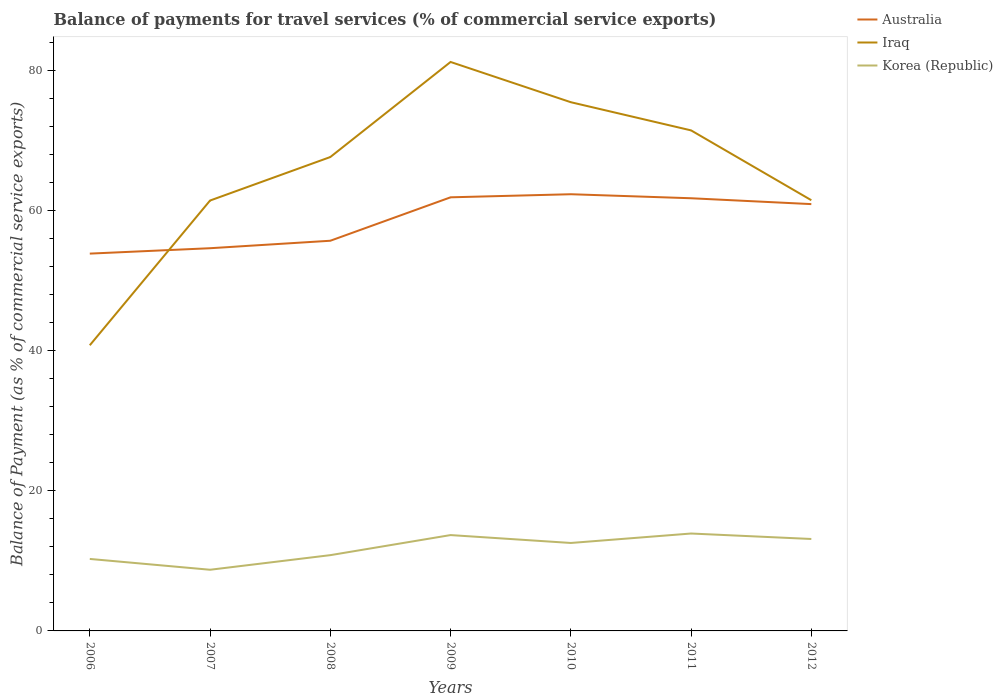Does the line corresponding to Iraq intersect with the line corresponding to Australia?
Keep it short and to the point. Yes. Across all years, what is the maximum balance of payments for travel services in Australia?
Make the answer very short. 53.87. In which year was the balance of payments for travel services in Korea (Republic) maximum?
Provide a short and direct response. 2007. What is the total balance of payments for travel services in Korea (Republic) in the graph?
Make the answer very short. 1.13. What is the difference between the highest and the second highest balance of payments for travel services in Australia?
Ensure brevity in your answer.  8.48. What is the difference between the highest and the lowest balance of payments for travel services in Iraq?
Offer a terse response. 4. Is the balance of payments for travel services in Australia strictly greater than the balance of payments for travel services in Iraq over the years?
Make the answer very short. No. Are the values on the major ticks of Y-axis written in scientific E-notation?
Your answer should be very brief. No. Where does the legend appear in the graph?
Keep it short and to the point. Top right. What is the title of the graph?
Your answer should be very brief. Balance of payments for travel services (% of commercial service exports). What is the label or title of the Y-axis?
Ensure brevity in your answer.  Balance of Payment (as % of commercial service exports). What is the Balance of Payment (as % of commercial service exports) of Australia in 2006?
Offer a terse response. 53.87. What is the Balance of Payment (as % of commercial service exports) in Iraq in 2006?
Provide a short and direct response. 40.79. What is the Balance of Payment (as % of commercial service exports) in Korea (Republic) in 2006?
Offer a very short reply. 10.28. What is the Balance of Payment (as % of commercial service exports) in Australia in 2007?
Your response must be concise. 54.64. What is the Balance of Payment (as % of commercial service exports) in Iraq in 2007?
Your answer should be compact. 61.45. What is the Balance of Payment (as % of commercial service exports) of Korea (Republic) in 2007?
Ensure brevity in your answer.  8.73. What is the Balance of Payment (as % of commercial service exports) in Australia in 2008?
Make the answer very short. 55.71. What is the Balance of Payment (as % of commercial service exports) of Iraq in 2008?
Make the answer very short. 67.66. What is the Balance of Payment (as % of commercial service exports) of Korea (Republic) in 2008?
Keep it short and to the point. 10.82. What is the Balance of Payment (as % of commercial service exports) of Australia in 2009?
Your answer should be very brief. 61.91. What is the Balance of Payment (as % of commercial service exports) of Iraq in 2009?
Your answer should be compact. 81.24. What is the Balance of Payment (as % of commercial service exports) in Korea (Republic) in 2009?
Provide a succinct answer. 13.68. What is the Balance of Payment (as % of commercial service exports) of Australia in 2010?
Ensure brevity in your answer.  62.35. What is the Balance of Payment (as % of commercial service exports) of Iraq in 2010?
Your response must be concise. 75.49. What is the Balance of Payment (as % of commercial service exports) of Korea (Republic) in 2010?
Offer a terse response. 12.56. What is the Balance of Payment (as % of commercial service exports) in Australia in 2011?
Make the answer very short. 61.78. What is the Balance of Payment (as % of commercial service exports) in Iraq in 2011?
Provide a short and direct response. 71.47. What is the Balance of Payment (as % of commercial service exports) in Korea (Republic) in 2011?
Your answer should be very brief. 13.91. What is the Balance of Payment (as % of commercial service exports) in Australia in 2012?
Ensure brevity in your answer.  60.94. What is the Balance of Payment (as % of commercial service exports) of Iraq in 2012?
Ensure brevity in your answer.  61.5. What is the Balance of Payment (as % of commercial service exports) of Korea (Republic) in 2012?
Provide a succinct answer. 13.13. Across all years, what is the maximum Balance of Payment (as % of commercial service exports) in Australia?
Make the answer very short. 62.35. Across all years, what is the maximum Balance of Payment (as % of commercial service exports) in Iraq?
Make the answer very short. 81.24. Across all years, what is the maximum Balance of Payment (as % of commercial service exports) in Korea (Republic)?
Offer a terse response. 13.91. Across all years, what is the minimum Balance of Payment (as % of commercial service exports) in Australia?
Keep it short and to the point. 53.87. Across all years, what is the minimum Balance of Payment (as % of commercial service exports) of Iraq?
Offer a very short reply. 40.79. Across all years, what is the minimum Balance of Payment (as % of commercial service exports) in Korea (Republic)?
Offer a terse response. 8.73. What is the total Balance of Payment (as % of commercial service exports) of Australia in the graph?
Your answer should be very brief. 411.21. What is the total Balance of Payment (as % of commercial service exports) in Iraq in the graph?
Your answer should be very brief. 459.59. What is the total Balance of Payment (as % of commercial service exports) of Korea (Republic) in the graph?
Give a very brief answer. 83.11. What is the difference between the Balance of Payment (as % of commercial service exports) in Australia in 2006 and that in 2007?
Give a very brief answer. -0.77. What is the difference between the Balance of Payment (as % of commercial service exports) in Iraq in 2006 and that in 2007?
Provide a short and direct response. -20.66. What is the difference between the Balance of Payment (as % of commercial service exports) in Korea (Republic) in 2006 and that in 2007?
Give a very brief answer. 1.54. What is the difference between the Balance of Payment (as % of commercial service exports) in Australia in 2006 and that in 2008?
Make the answer very short. -1.83. What is the difference between the Balance of Payment (as % of commercial service exports) of Iraq in 2006 and that in 2008?
Give a very brief answer. -26.88. What is the difference between the Balance of Payment (as % of commercial service exports) in Korea (Republic) in 2006 and that in 2008?
Offer a terse response. -0.54. What is the difference between the Balance of Payment (as % of commercial service exports) of Australia in 2006 and that in 2009?
Provide a succinct answer. -8.04. What is the difference between the Balance of Payment (as % of commercial service exports) in Iraq in 2006 and that in 2009?
Your answer should be compact. -40.45. What is the difference between the Balance of Payment (as % of commercial service exports) of Korea (Republic) in 2006 and that in 2009?
Give a very brief answer. -3.41. What is the difference between the Balance of Payment (as % of commercial service exports) in Australia in 2006 and that in 2010?
Provide a succinct answer. -8.48. What is the difference between the Balance of Payment (as % of commercial service exports) in Iraq in 2006 and that in 2010?
Offer a very short reply. -34.7. What is the difference between the Balance of Payment (as % of commercial service exports) in Korea (Republic) in 2006 and that in 2010?
Provide a succinct answer. -2.28. What is the difference between the Balance of Payment (as % of commercial service exports) of Australia in 2006 and that in 2011?
Keep it short and to the point. -7.9. What is the difference between the Balance of Payment (as % of commercial service exports) of Iraq in 2006 and that in 2011?
Give a very brief answer. -30.68. What is the difference between the Balance of Payment (as % of commercial service exports) of Korea (Republic) in 2006 and that in 2011?
Give a very brief answer. -3.63. What is the difference between the Balance of Payment (as % of commercial service exports) of Australia in 2006 and that in 2012?
Provide a succinct answer. -7.07. What is the difference between the Balance of Payment (as % of commercial service exports) in Iraq in 2006 and that in 2012?
Offer a terse response. -20.71. What is the difference between the Balance of Payment (as % of commercial service exports) of Korea (Republic) in 2006 and that in 2012?
Your answer should be very brief. -2.85. What is the difference between the Balance of Payment (as % of commercial service exports) in Australia in 2007 and that in 2008?
Your answer should be compact. -1.07. What is the difference between the Balance of Payment (as % of commercial service exports) in Iraq in 2007 and that in 2008?
Your response must be concise. -6.21. What is the difference between the Balance of Payment (as % of commercial service exports) of Korea (Republic) in 2007 and that in 2008?
Give a very brief answer. -2.08. What is the difference between the Balance of Payment (as % of commercial service exports) in Australia in 2007 and that in 2009?
Your answer should be very brief. -7.27. What is the difference between the Balance of Payment (as % of commercial service exports) in Iraq in 2007 and that in 2009?
Provide a short and direct response. -19.79. What is the difference between the Balance of Payment (as % of commercial service exports) of Korea (Republic) in 2007 and that in 2009?
Offer a terse response. -4.95. What is the difference between the Balance of Payment (as % of commercial service exports) of Australia in 2007 and that in 2010?
Keep it short and to the point. -7.71. What is the difference between the Balance of Payment (as % of commercial service exports) in Iraq in 2007 and that in 2010?
Provide a succinct answer. -14.04. What is the difference between the Balance of Payment (as % of commercial service exports) in Korea (Republic) in 2007 and that in 2010?
Provide a short and direct response. -3.82. What is the difference between the Balance of Payment (as % of commercial service exports) of Australia in 2007 and that in 2011?
Your answer should be compact. -7.13. What is the difference between the Balance of Payment (as % of commercial service exports) in Iraq in 2007 and that in 2011?
Ensure brevity in your answer.  -10.02. What is the difference between the Balance of Payment (as % of commercial service exports) in Korea (Republic) in 2007 and that in 2011?
Your response must be concise. -5.17. What is the difference between the Balance of Payment (as % of commercial service exports) in Australia in 2007 and that in 2012?
Provide a succinct answer. -6.3. What is the difference between the Balance of Payment (as % of commercial service exports) of Iraq in 2007 and that in 2012?
Make the answer very short. -0.05. What is the difference between the Balance of Payment (as % of commercial service exports) in Korea (Republic) in 2007 and that in 2012?
Provide a succinct answer. -4.39. What is the difference between the Balance of Payment (as % of commercial service exports) in Australia in 2008 and that in 2009?
Provide a succinct answer. -6.2. What is the difference between the Balance of Payment (as % of commercial service exports) of Iraq in 2008 and that in 2009?
Your response must be concise. -13.57. What is the difference between the Balance of Payment (as % of commercial service exports) in Korea (Republic) in 2008 and that in 2009?
Keep it short and to the point. -2.87. What is the difference between the Balance of Payment (as % of commercial service exports) of Australia in 2008 and that in 2010?
Make the answer very short. -6.64. What is the difference between the Balance of Payment (as % of commercial service exports) of Iraq in 2008 and that in 2010?
Your answer should be compact. -7.83. What is the difference between the Balance of Payment (as % of commercial service exports) in Korea (Republic) in 2008 and that in 2010?
Your response must be concise. -1.74. What is the difference between the Balance of Payment (as % of commercial service exports) of Australia in 2008 and that in 2011?
Your answer should be very brief. -6.07. What is the difference between the Balance of Payment (as % of commercial service exports) in Iraq in 2008 and that in 2011?
Your response must be concise. -3.81. What is the difference between the Balance of Payment (as % of commercial service exports) in Korea (Republic) in 2008 and that in 2011?
Give a very brief answer. -3.09. What is the difference between the Balance of Payment (as % of commercial service exports) of Australia in 2008 and that in 2012?
Keep it short and to the point. -5.23. What is the difference between the Balance of Payment (as % of commercial service exports) of Iraq in 2008 and that in 2012?
Your answer should be very brief. 6.16. What is the difference between the Balance of Payment (as % of commercial service exports) of Korea (Republic) in 2008 and that in 2012?
Your response must be concise. -2.31. What is the difference between the Balance of Payment (as % of commercial service exports) of Australia in 2009 and that in 2010?
Give a very brief answer. -0.44. What is the difference between the Balance of Payment (as % of commercial service exports) of Iraq in 2009 and that in 2010?
Provide a short and direct response. 5.75. What is the difference between the Balance of Payment (as % of commercial service exports) of Korea (Republic) in 2009 and that in 2010?
Your answer should be very brief. 1.13. What is the difference between the Balance of Payment (as % of commercial service exports) in Australia in 2009 and that in 2011?
Ensure brevity in your answer.  0.13. What is the difference between the Balance of Payment (as % of commercial service exports) in Iraq in 2009 and that in 2011?
Keep it short and to the point. 9.77. What is the difference between the Balance of Payment (as % of commercial service exports) in Korea (Republic) in 2009 and that in 2011?
Offer a very short reply. -0.22. What is the difference between the Balance of Payment (as % of commercial service exports) in Australia in 2009 and that in 2012?
Ensure brevity in your answer.  0.97. What is the difference between the Balance of Payment (as % of commercial service exports) in Iraq in 2009 and that in 2012?
Your answer should be compact. 19.74. What is the difference between the Balance of Payment (as % of commercial service exports) of Korea (Republic) in 2009 and that in 2012?
Your answer should be very brief. 0.56. What is the difference between the Balance of Payment (as % of commercial service exports) in Australia in 2010 and that in 2011?
Give a very brief answer. 0.57. What is the difference between the Balance of Payment (as % of commercial service exports) in Iraq in 2010 and that in 2011?
Keep it short and to the point. 4.02. What is the difference between the Balance of Payment (as % of commercial service exports) in Korea (Republic) in 2010 and that in 2011?
Offer a terse response. -1.35. What is the difference between the Balance of Payment (as % of commercial service exports) of Australia in 2010 and that in 2012?
Offer a terse response. 1.41. What is the difference between the Balance of Payment (as % of commercial service exports) in Iraq in 2010 and that in 2012?
Your response must be concise. 13.99. What is the difference between the Balance of Payment (as % of commercial service exports) of Korea (Republic) in 2010 and that in 2012?
Offer a very short reply. -0.57. What is the difference between the Balance of Payment (as % of commercial service exports) of Australia in 2011 and that in 2012?
Give a very brief answer. 0.84. What is the difference between the Balance of Payment (as % of commercial service exports) in Iraq in 2011 and that in 2012?
Make the answer very short. 9.97. What is the difference between the Balance of Payment (as % of commercial service exports) of Korea (Republic) in 2011 and that in 2012?
Your response must be concise. 0.78. What is the difference between the Balance of Payment (as % of commercial service exports) of Australia in 2006 and the Balance of Payment (as % of commercial service exports) of Iraq in 2007?
Your answer should be compact. -7.58. What is the difference between the Balance of Payment (as % of commercial service exports) in Australia in 2006 and the Balance of Payment (as % of commercial service exports) in Korea (Republic) in 2007?
Your response must be concise. 45.14. What is the difference between the Balance of Payment (as % of commercial service exports) of Iraq in 2006 and the Balance of Payment (as % of commercial service exports) of Korea (Republic) in 2007?
Provide a succinct answer. 32.05. What is the difference between the Balance of Payment (as % of commercial service exports) of Australia in 2006 and the Balance of Payment (as % of commercial service exports) of Iraq in 2008?
Ensure brevity in your answer.  -13.79. What is the difference between the Balance of Payment (as % of commercial service exports) of Australia in 2006 and the Balance of Payment (as % of commercial service exports) of Korea (Republic) in 2008?
Keep it short and to the point. 43.06. What is the difference between the Balance of Payment (as % of commercial service exports) in Iraq in 2006 and the Balance of Payment (as % of commercial service exports) in Korea (Republic) in 2008?
Your answer should be compact. 29.97. What is the difference between the Balance of Payment (as % of commercial service exports) in Australia in 2006 and the Balance of Payment (as % of commercial service exports) in Iraq in 2009?
Your answer should be compact. -27.36. What is the difference between the Balance of Payment (as % of commercial service exports) in Australia in 2006 and the Balance of Payment (as % of commercial service exports) in Korea (Republic) in 2009?
Your answer should be very brief. 40.19. What is the difference between the Balance of Payment (as % of commercial service exports) of Iraq in 2006 and the Balance of Payment (as % of commercial service exports) of Korea (Republic) in 2009?
Provide a succinct answer. 27.1. What is the difference between the Balance of Payment (as % of commercial service exports) of Australia in 2006 and the Balance of Payment (as % of commercial service exports) of Iraq in 2010?
Your answer should be very brief. -21.62. What is the difference between the Balance of Payment (as % of commercial service exports) of Australia in 2006 and the Balance of Payment (as % of commercial service exports) of Korea (Republic) in 2010?
Offer a terse response. 41.32. What is the difference between the Balance of Payment (as % of commercial service exports) of Iraq in 2006 and the Balance of Payment (as % of commercial service exports) of Korea (Republic) in 2010?
Offer a terse response. 28.23. What is the difference between the Balance of Payment (as % of commercial service exports) in Australia in 2006 and the Balance of Payment (as % of commercial service exports) in Iraq in 2011?
Your answer should be very brief. -17.59. What is the difference between the Balance of Payment (as % of commercial service exports) of Australia in 2006 and the Balance of Payment (as % of commercial service exports) of Korea (Republic) in 2011?
Give a very brief answer. 39.97. What is the difference between the Balance of Payment (as % of commercial service exports) of Iraq in 2006 and the Balance of Payment (as % of commercial service exports) of Korea (Republic) in 2011?
Give a very brief answer. 26.88. What is the difference between the Balance of Payment (as % of commercial service exports) in Australia in 2006 and the Balance of Payment (as % of commercial service exports) in Iraq in 2012?
Your response must be concise. -7.62. What is the difference between the Balance of Payment (as % of commercial service exports) of Australia in 2006 and the Balance of Payment (as % of commercial service exports) of Korea (Republic) in 2012?
Ensure brevity in your answer.  40.75. What is the difference between the Balance of Payment (as % of commercial service exports) of Iraq in 2006 and the Balance of Payment (as % of commercial service exports) of Korea (Republic) in 2012?
Provide a short and direct response. 27.66. What is the difference between the Balance of Payment (as % of commercial service exports) in Australia in 2007 and the Balance of Payment (as % of commercial service exports) in Iraq in 2008?
Offer a very short reply. -13.02. What is the difference between the Balance of Payment (as % of commercial service exports) in Australia in 2007 and the Balance of Payment (as % of commercial service exports) in Korea (Republic) in 2008?
Ensure brevity in your answer.  43.82. What is the difference between the Balance of Payment (as % of commercial service exports) in Iraq in 2007 and the Balance of Payment (as % of commercial service exports) in Korea (Republic) in 2008?
Your response must be concise. 50.63. What is the difference between the Balance of Payment (as % of commercial service exports) in Australia in 2007 and the Balance of Payment (as % of commercial service exports) in Iraq in 2009?
Ensure brevity in your answer.  -26.59. What is the difference between the Balance of Payment (as % of commercial service exports) of Australia in 2007 and the Balance of Payment (as % of commercial service exports) of Korea (Republic) in 2009?
Your answer should be very brief. 40.96. What is the difference between the Balance of Payment (as % of commercial service exports) of Iraq in 2007 and the Balance of Payment (as % of commercial service exports) of Korea (Republic) in 2009?
Offer a terse response. 47.77. What is the difference between the Balance of Payment (as % of commercial service exports) in Australia in 2007 and the Balance of Payment (as % of commercial service exports) in Iraq in 2010?
Offer a very short reply. -20.85. What is the difference between the Balance of Payment (as % of commercial service exports) of Australia in 2007 and the Balance of Payment (as % of commercial service exports) of Korea (Republic) in 2010?
Provide a short and direct response. 42.09. What is the difference between the Balance of Payment (as % of commercial service exports) of Iraq in 2007 and the Balance of Payment (as % of commercial service exports) of Korea (Republic) in 2010?
Your response must be concise. 48.89. What is the difference between the Balance of Payment (as % of commercial service exports) of Australia in 2007 and the Balance of Payment (as % of commercial service exports) of Iraq in 2011?
Offer a very short reply. -16.83. What is the difference between the Balance of Payment (as % of commercial service exports) of Australia in 2007 and the Balance of Payment (as % of commercial service exports) of Korea (Republic) in 2011?
Provide a succinct answer. 40.74. What is the difference between the Balance of Payment (as % of commercial service exports) in Iraq in 2007 and the Balance of Payment (as % of commercial service exports) in Korea (Republic) in 2011?
Your answer should be compact. 47.54. What is the difference between the Balance of Payment (as % of commercial service exports) in Australia in 2007 and the Balance of Payment (as % of commercial service exports) in Iraq in 2012?
Provide a succinct answer. -6.85. What is the difference between the Balance of Payment (as % of commercial service exports) of Australia in 2007 and the Balance of Payment (as % of commercial service exports) of Korea (Republic) in 2012?
Your answer should be compact. 41.52. What is the difference between the Balance of Payment (as % of commercial service exports) of Iraq in 2007 and the Balance of Payment (as % of commercial service exports) of Korea (Republic) in 2012?
Make the answer very short. 48.32. What is the difference between the Balance of Payment (as % of commercial service exports) of Australia in 2008 and the Balance of Payment (as % of commercial service exports) of Iraq in 2009?
Provide a short and direct response. -25.53. What is the difference between the Balance of Payment (as % of commercial service exports) of Australia in 2008 and the Balance of Payment (as % of commercial service exports) of Korea (Republic) in 2009?
Provide a short and direct response. 42.02. What is the difference between the Balance of Payment (as % of commercial service exports) of Iraq in 2008 and the Balance of Payment (as % of commercial service exports) of Korea (Republic) in 2009?
Offer a terse response. 53.98. What is the difference between the Balance of Payment (as % of commercial service exports) in Australia in 2008 and the Balance of Payment (as % of commercial service exports) in Iraq in 2010?
Give a very brief answer. -19.78. What is the difference between the Balance of Payment (as % of commercial service exports) of Australia in 2008 and the Balance of Payment (as % of commercial service exports) of Korea (Republic) in 2010?
Your answer should be compact. 43.15. What is the difference between the Balance of Payment (as % of commercial service exports) of Iraq in 2008 and the Balance of Payment (as % of commercial service exports) of Korea (Republic) in 2010?
Provide a short and direct response. 55.1. What is the difference between the Balance of Payment (as % of commercial service exports) in Australia in 2008 and the Balance of Payment (as % of commercial service exports) in Iraq in 2011?
Provide a succinct answer. -15.76. What is the difference between the Balance of Payment (as % of commercial service exports) in Australia in 2008 and the Balance of Payment (as % of commercial service exports) in Korea (Republic) in 2011?
Provide a short and direct response. 41.8. What is the difference between the Balance of Payment (as % of commercial service exports) of Iraq in 2008 and the Balance of Payment (as % of commercial service exports) of Korea (Republic) in 2011?
Your response must be concise. 53.76. What is the difference between the Balance of Payment (as % of commercial service exports) in Australia in 2008 and the Balance of Payment (as % of commercial service exports) in Iraq in 2012?
Your answer should be compact. -5.79. What is the difference between the Balance of Payment (as % of commercial service exports) in Australia in 2008 and the Balance of Payment (as % of commercial service exports) in Korea (Republic) in 2012?
Give a very brief answer. 42.58. What is the difference between the Balance of Payment (as % of commercial service exports) in Iraq in 2008 and the Balance of Payment (as % of commercial service exports) in Korea (Republic) in 2012?
Provide a succinct answer. 54.54. What is the difference between the Balance of Payment (as % of commercial service exports) in Australia in 2009 and the Balance of Payment (as % of commercial service exports) in Iraq in 2010?
Your answer should be very brief. -13.58. What is the difference between the Balance of Payment (as % of commercial service exports) in Australia in 2009 and the Balance of Payment (as % of commercial service exports) in Korea (Republic) in 2010?
Ensure brevity in your answer.  49.35. What is the difference between the Balance of Payment (as % of commercial service exports) in Iraq in 2009 and the Balance of Payment (as % of commercial service exports) in Korea (Republic) in 2010?
Make the answer very short. 68.68. What is the difference between the Balance of Payment (as % of commercial service exports) of Australia in 2009 and the Balance of Payment (as % of commercial service exports) of Iraq in 2011?
Your response must be concise. -9.56. What is the difference between the Balance of Payment (as % of commercial service exports) of Australia in 2009 and the Balance of Payment (as % of commercial service exports) of Korea (Republic) in 2011?
Keep it short and to the point. 48. What is the difference between the Balance of Payment (as % of commercial service exports) in Iraq in 2009 and the Balance of Payment (as % of commercial service exports) in Korea (Republic) in 2011?
Keep it short and to the point. 67.33. What is the difference between the Balance of Payment (as % of commercial service exports) in Australia in 2009 and the Balance of Payment (as % of commercial service exports) in Iraq in 2012?
Your response must be concise. 0.41. What is the difference between the Balance of Payment (as % of commercial service exports) of Australia in 2009 and the Balance of Payment (as % of commercial service exports) of Korea (Republic) in 2012?
Your answer should be very brief. 48.78. What is the difference between the Balance of Payment (as % of commercial service exports) in Iraq in 2009 and the Balance of Payment (as % of commercial service exports) in Korea (Republic) in 2012?
Your response must be concise. 68.11. What is the difference between the Balance of Payment (as % of commercial service exports) in Australia in 2010 and the Balance of Payment (as % of commercial service exports) in Iraq in 2011?
Your answer should be very brief. -9.12. What is the difference between the Balance of Payment (as % of commercial service exports) of Australia in 2010 and the Balance of Payment (as % of commercial service exports) of Korea (Republic) in 2011?
Your answer should be very brief. 48.45. What is the difference between the Balance of Payment (as % of commercial service exports) of Iraq in 2010 and the Balance of Payment (as % of commercial service exports) of Korea (Republic) in 2011?
Your answer should be compact. 61.58. What is the difference between the Balance of Payment (as % of commercial service exports) in Australia in 2010 and the Balance of Payment (as % of commercial service exports) in Iraq in 2012?
Give a very brief answer. 0.85. What is the difference between the Balance of Payment (as % of commercial service exports) of Australia in 2010 and the Balance of Payment (as % of commercial service exports) of Korea (Republic) in 2012?
Make the answer very short. 49.23. What is the difference between the Balance of Payment (as % of commercial service exports) of Iraq in 2010 and the Balance of Payment (as % of commercial service exports) of Korea (Republic) in 2012?
Keep it short and to the point. 62.36. What is the difference between the Balance of Payment (as % of commercial service exports) of Australia in 2011 and the Balance of Payment (as % of commercial service exports) of Iraq in 2012?
Ensure brevity in your answer.  0.28. What is the difference between the Balance of Payment (as % of commercial service exports) in Australia in 2011 and the Balance of Payment (as % of commercial service exports) in Korea (Republic) in 2012?
Your answer should be very brief. 48.65. What is the difference between the Balance of Payment (as % of commercial service exports) in Iraq in 2011 and the Balance of Payment (as % of commercial service exports) in Korea (Republic) in 2012?
Give a very brief answer. 58.34. What is the average Balance of Payment (as % of commercial service exports) in Australia per year?
Your response must be concise. 58.74. What is the average Balance of Payment (as % of commercial service exports) of Iraq per year?
Offer a very short reply. 65.66. What is the average Balance of Payment (as % of commercial service exports) of Korea (Republic) per year?
Provide a short and direct response. 11.87. In the year 2006, what is the difference between the Balance of Payment (as % of commercial service exports) in Australia and Balance of Payment (as % of commercial service exports) in Iraq?
Give a very brief answer. 13.09. In the year 2006, what is the difference between the Balance of Payment (as % of commercial service exports) in Australia and Balance of Payment (as % of commercial service exports) in Korea (Republic)?
Offer a very short reply. 43.6. In the year 2006, what is the difference between the Balance of Payment (as % of commercial service exports) of Iraq and Balance of Payment (as % of commercial service exports) of Korea (Republic)?
Your answer should be very brief. 30.51. In the year 2007, what is the difference between the Balance of Payment (as % of commercial service exports) in Australia and Balance of Payment (as % of commercial service exports) in Iraq?
Offer a very short reply. -6.81. In the year 2007, what is the difference between the Balance of Payment (as % of commercial service exports) of Australia and Balance of Payment (as % of commercial service exports) of Korea (Republic)?
Provide a short and direct response. 45.91. In the year 2007, what is the difference between the Balance of Payment (as % of commercial service exports) of Iraq and Balance of Payment (as % of commercial service exports) of Korea (Republic)?
Your response must be concise. 52.72. In the year 2008, what is the difference between the Balance of Payment (as % of commercial service exports) of Australia and Balance of Payment (as % of commercial service exports) of Iraq?
Provide a succinct answer. -11.95. In the year 2008, what is the difference between the Balance of Payment (as % of commercial service exports) in Australia and Balance of Payment (as % of commercial service exports) in Korea (Republic)?
Offer a very short reply. 44.89. In the year 2008, what is the difference between the Balance of Payment (as % of commercial service exports) in Iraq and Balance of Payment (as % of commercial service exports) in Korea (Republic)?
Make the answer very short. 56.84. In the year 2009, what is the difference between the Balance of Payment (as % of commercial service exports) of Australia and Balance of Payment (as % of commercial service exports) of Iraq?
Give a very brief answer. -19.33. In the year 2009, what is the difference between the Balance of Payment (as % of commercial service exports) of Australia and Balance of Payment (as % of commercial service exports) of Korea (Republic)?
Provide a short and direct response. 48.23. In the year 2009, what is the difference between the Balance of Payment (as % of commercial service exports) in Iraq and Balance of Payment (as % of commercial service exports) in Korea (Republic)?
Ensure brevity in your answer.  67.55. In the year 2010, what is the difference between the Balance of Payment (as % of commercial service exports) of Australia and Balance of Payment (as % of commercial service exports) of Iraq?
Offer a very short reply. -13.14. In the year 2010, what is the difference between the Balance of Payment (as % of commercial service exports) in Australia and Balance of Payment (as % of commercial service exports) in Korea (Republic)?
Offer a very short reply. 49.79. In the year 2010, what is the difference between the Balance of Payment (as % of commercial service exports) of Iraq and Balance of Payment (as % of commercial service exports) of Korea (Republic)?
Provide a succinct answer. 62.93. In the year 2011, what is the difference between the Balance of Payment (as % of commercial service exports) of Australia and Balance of Payment (as % of commercial service exports) of Iraq?
Make the answer very short. -9.69. In the year 2011, what is the difference between the Balance of Payment (as % of commercial service exports) in Australia and Balance of Payment (as % of commercial service exports) in Korea (Republic)?
Provide a short and direct response. 47.87. In the year 2011, what is the difference between the Balance of Payment (as % of commercial service exports) in Iraq and Balance of Payment (as % of commercial service exports) in Korea (Republic)?
Make the answer very short. 57.56. In the year 2012, what is the difference between the Balance of Payment (as % of commercial service exports) of Australia and Balance of Payment (as % of commercial service exports) of Iraq?
Give a very brief answer. -0.56. In the year 2012, what is the difference between the Balance of Payment (as % of commercial service exports) in Australia and Balance of Payment (as % of commercial service exports) in Korea (Republic)?
Keep it short and to the point. 47.82. In the year 2012, what is the difference between the Balance of Payment (as % of commercial service exports) in Iraq and Balance of Payment (as % of commercial service exports) in Korea (Republic)?
Offer a terse response. 48.37. What is the ratio of the Balance of Payment (as % of commercial service exports) of Australia in 2006 to that in 2007?
Make the answer very short. 0.99. What is the ratio of the Balance of Payment (as % of commercial service exports) of Iraq in 2006 to that in 2007?
Offer a terse response. 0.66. What is the ratio of the Balance of Payment (as % of commercial service exports) of Korea (Republic) in 2006 to that in 2007?
Your answer should be very brief. 1.18. What is the ratio of the Balance of Payment (as % of commercial service exports) of Australia in 2006 to that in 2008?
Your response must be concise. 0.97. What is the ratio of the Balance of Payment (as % of commercial service exports) in Iraq in 2006 to that in 2008?
Provide a short and direct response. 0.6. What is the ratio of the Balance of Payment (as % of commercial service exports) in Korea (Republic) in 2006 to that in 2008?
Offer a terse response. 0.95. What is the ratio of the Balance of Payment (as % of commercial service exports) in Australia in 2006 to that in 2009?
Your answer should be very brief. 0.87. What is the ratio of the Balance of Payment (as % of commercial service exports) of Iraq in 2006 to that in 2009?
Your answer should be compact. 0.5. What is the ratio of the Balance of Payment (as % of commercial service exports) in Korea (Republic) in 2006 to that in 2009?
Offer a very short reply. 0.75. What is the ratio of the Balance of Payment (as % of commercial service exports) of Australia in 2006 to that in 2010?
Provide a short and direct response. 0.86. What is the ratio of the Balance of Payment (as % of commercial service exports) of Iraq in 2006 to that in 2010?
Offer a very short reply. 0.54. What is the ratio of the Balance of Payment (as % of commercial service exports) of Korea (Republic) in 2006 to that in 2010?
Your answer should be compact. 0.82. What is the ratio of the Balance of Payment (as % of commercial service exports) in Australia in 2006 to that in 2011?
Provide a short and direct response. 0.87. What is the ratio of the Balance of Payment (as % of commercial service exports) of Iraq in 2006 to that in 2011?
Ensure brevity in your answer.  0.57. What is the ratio of the Balance of Payment (as % of commercial service exports) in Korea (Republic) in 2006 to that in 2011?
Your response must be concise. 0.74. What is the ratio of the Balance of Payment (as % of commercial service exports) of Australia in 2006 to that in 2012?
Offer a very short reply. 0.88. What is the ratio of the Balance of Payment (as % of commercial service exports) of Iraq in 2006 to that in 2012?
Offer a very short reply. 0.66. What is the ratio of the Balance of Payment (as % of commercial service exports) in Korea (Republic) in 2006 to that in 2012?
Give a very brief answer. 0.78. What is the ratio of the Balance of Payment (as % of commercial service exports) of Australia in 2007 to that in 2008?
Ensure brevity in your answer.  0.98. What is the ratio of the Balance of Payment (as % of commercial service exports) of Iraq in 2007 to that in 2008?
Provide a short and direct response. 0.91. What is the ratio of the Balance of Payment (as % of commercial service exports) of Korea (Republic) in 2007 to that in 2008?
Give a very brief answer. 0.81. What is the ratio of the Balance of Payment (as % of commercial service exports) in Australia in 2007 to that in 2009?
Your answer should be compact. 0.88. What is the ratio of the Balance of Payment (as % of commercial service exports) in Iraq in 2007 to that in 2009?
Give a very brief answer. 0.76. What is the ratio of the Balance of Payment (as % of commercial service exports) in Korea (Republic) in 2007 to that in 2009?
Give a very brief answer. 0.64. What is the ratio of the Balance of Payment (as % of commercial service exports) of Australia in 2007 to that in 2010?
Offer a very short reply. 0.88. What is the ratio of the Balance of Payment (as % of commercial service exports) in Iraq in 2007 to that in 2010?
Your answer should be compact. 0.81. What is the ratio of the Balance of Payment (as % of commercial service exports) of Korea (Republic) in 2007 to that in 2010?
Your response must be concise. 0.7. What is the ratio of the Balance of Payment (as % of commercial service exports) in Australia in 2007 to that in 2011?
Make the answer very short. 0.88. What is the ratio of the Balance of Payment (as % of commercial service exports) in Iraq in 2007 to that in 2011?
Keep it short and to the point. 0.86. What is the ratio of the Balance of Payment (as % of commercial service exports) in Korea (Republic) in 2007 to that in 2011?
Provide a short and direct response. 0.63. What is the ratio of the Balance of Payment (as % of commercial service exports) in Australia in 2007 to that in 2012?
Make the answer very short. 0.9. What is the ratio of the Balance of Payment (as % of commercial service exports) of Iraq in 2007 to that in 2012?
Offer a very short reply. 1. What is the ratio of the Balance of Payment (as % of commercial service exports) in Korea (Republic) in 2007 to that in 2012?
Give a very brief answer. 0.67. What is the ratio of the Balance of Payment (as % of commercial service exports) of Australia in 2008 to that in 2009?
Your answer should be very brief. 0.9. What is the ratio of the Balance of Payment (as % of commercial service exports) of Iraq in 2008 to that in 2009?
Offer a terse response. 0.83. What is the ratio of the Balance of Payment (as % of commercial service exports) of Korea (Republic) in 2008 to that in 2009?
Keep it short and to the point. 0.79. What is the ratio of the Balance of Payment (as % of commercial service exports) in Australia in 2008 to that in 2010?
Provide a short and direct response. 0.89. What is the ratio of the Balance of Payment (as % of commercial service exports) of Iraq in 2008 to that in 2010?
Offer a very short reply. 0.9. What is the ratio of the Balance of Payment (as % of commercial service exports) of Korea (Republic) in 2008 to that in 2010?
Your response must be concise. 0.86. What is the ratio of the Balance of Payment (as % of commercial service exports) of Australia in 2008 to that in 2011?
Your answer should be very brief. 0.9. What is the ratio of the Balance of Payment (as % of commercial service exports) in Iraq in 2008 to that in 2011?
Your answer should be compact. 0.95. What is the ratio of the Balance of Payment (as % of commercial service exports) in Korea (Republic) in 2008 to that in 2011?
Ensure brevity in your answer.  0.78. What is the ratio of the Balance of Payment (as % of commercial service exports) of Australia in 2008 to that in 2012?
Ensure brevity in your answer.  0.91. What is the ratio of the Balance of Payment (as % of commercial service exports) in Iraq in 2008 to that in 2012?
Keep it short and to the point. 1.1. What is the ratio of the Balance of Payment (as % of commercial service exports) of Korea (Republic) in 2008 to that in 2012?
Keep it short and to the point. 0.82. What is the ratio of the Balance of Payment (as % of commercial service exports) of Australia in 2009 to that in 2010?
Offer a terse response. 0.99. What is the ratio of the Balance of Payment (as % of commercial service exports) in Iraq in 2009 to that in 2010?
Keep it short and to the point. 1.08. What is the ratio of the Balance of Payment (as % of commercial service exports) of Korea (Republic) in 2009 to that in 2010?
Make the answer very short. 1.09. What is the ratio of the Balance of Payment (as % of commercial service exports) of Australia in 2009 to that in 2011?
Ensure brevity in your answer.  1. What is the ratio of the Balance of Payment (as % of commercial service exports) of Iraq in 2009 to that in 2011?
Make the answer very short. 1.14. What is the ratio of the Balance of Payment (as % of commercial service exports) of Korea (Republic) in 2009 to that in 2011?
Your answer should be compact. 0.98. What is the ratio of the Balance of Payment (as % of commercial service exports) of Australia in 2009 to that in 2012?
Provide a succinct answer. 1.02. What is the ratio of the Balance of Payment (as % of commercial service exports) in Iraq in 2009 to that in 2012?
Provide a short and direct response. 1.32. What is the ratio of the Balance of Payment (as % of commercial service exports) of Korea (Republic) in 2009 to that in 2012?
Give a very brief answer. 1.04. What is the ratio of the Balance of Payment (as % of commercial service exports) of Australia in 2010 to that in 2011?
Ensure brevity in your answer.  1.01. What is the ratio of the Balance of Payment (as % of commercial service exports) of Iraq in 2010 to that in 2011?
Provide a succinct answer. 1.06. What is the ratio of the Balance of Payment (as % of commercial service exports) in Korea (Republic) in 2010 to that in 2011?
Give a very brief answer. 0.9. What is the ratio of the Balance of Payment (as % of commercial service exports) of Australia in 2010 to that in 2012?
Offer a terse response. 1.02. What is the ratio of the Balance of Payment (as % of commercial service exports) in Iraq in 2010 to that in 2012?
Ensure brevity in your answer.  1.23. What is the ratio of the Balance of Payment (as % of commercial service exports) of Korea (Republic) in 2010 to that in 2012?
Your answer should be very brief. 0.96. What is the ratio of the Balance of Payment (as % of commercial service exports) of Australia in 2011 to that in 2012?
Offer a terse response. 1.01. What is the ratio of the Balance of Payment (as % of commercial service exports) in Iraq in 2011 to that in 2012?
Ensure brevity in your answer.  1.16. What is the ratio of the Balance of Payment (as % of commercial service exports) of Korea (Republic) in 2011 to that in 2012?
Give a very brief answer. 1.06. What is the difference between the highest and the second highest Balance of Payment (as % of commercial service exports) of Australia?
Give a very brief answer. 0.44. What is the difference between the highest and the second highest Balance of Payment (as % of commercial service exports) of Iraq?
Make the answer very short. 5.75. What is the difference between the highest and the second highest Balance of Payment (as % of commercial service exports) in Korea (Republic)?
Give a very brief answer. 0.22. What is the difference between the highest and the lowest Balance of Payment (as % of commercial service exports) in Australia?
Give a very brief answer. 8.48. What is the difference between the highest and the lowest Balance of Payment (as % of commercial service exports) in Iraq?
Keep it short and to the point. 40.45. What is the difference between the highest and the lowest Balance of Payment (as % of commercial service exports) in Korea (Republic)?
Ensure brevity in your answer.  5.17. 